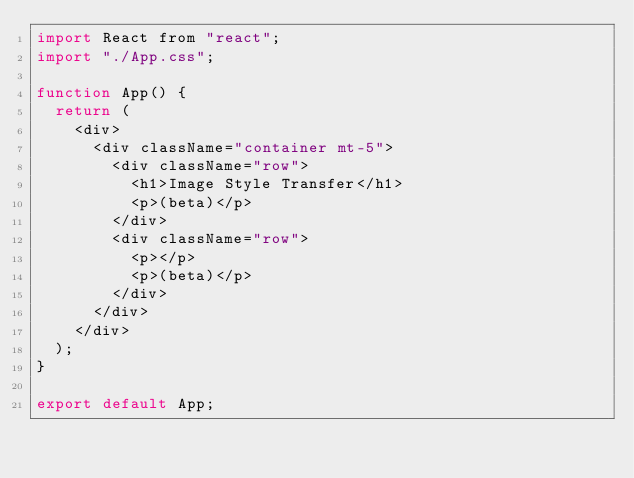Convert code to text. <code><loc_0><loc_0><loc_500><loc_500><_JavaScript_>import React from "react";
import "./App.css";

function App() {
  return (
    <div>
      <div className="container mt-5">
        <div className="row">
          <h1>Image Style Transfer</h1>
          <p>(beta)</p>
        </div>
        <div className="row">
          <p></p>
          <p>(beta)</p>
        </div>
      </div>
    </div>
  );
}

export default App;
</code> 